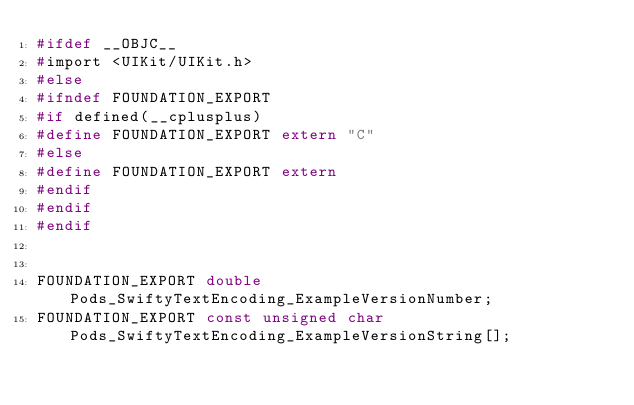Convert code to text. <code><loc_0><loc_0><loc_500><loc_500><_C_>#ifdef __OBJC__
#import <UIKit/UIKit.h>
#else
#ifndef FOUNDATION_EXPORT
#if defined(__cplusplus)
#define FOUNDATION_EXPORT extern "C"
#else
#define FOUNDATION_EXPORT extern
#endif
#endif
#endif


FOUNDATION_EXPORT double Pods_SwiftyTextEncoding_ExampleVersionNumber;
FOUNDATION_EXPORT const unsigned char Pods_SwiftyTextEncoding_ExampleVersionString[];

</code> 